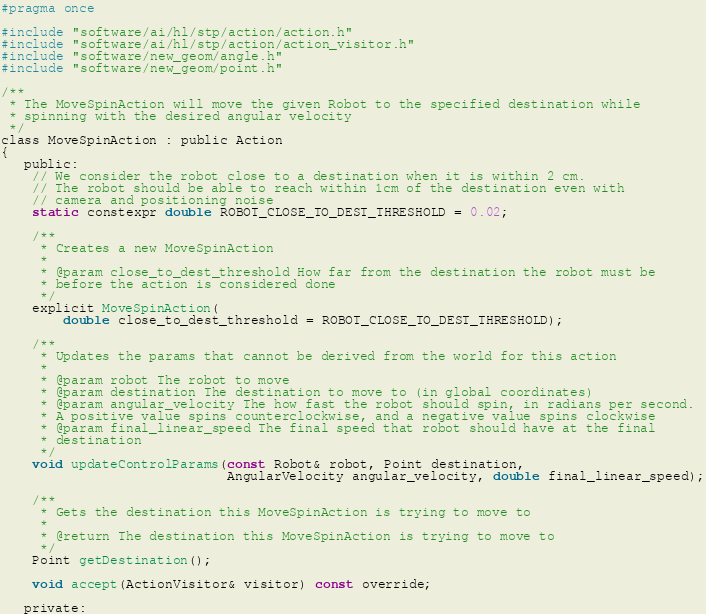<code> <loc_0><loc_0><loc_500><loc_500><_C_>#pragma once

#include "software/ai/hl/stp/action/action.h"
#include "software/ai/hl/stp/action/action_visitor.h"
#include "software/new_geom/angle.h"
#include "software/new_geom/point.h"

/**
 * The MoveSpinAction will move the given Robot to the specified destination while
 * spinning with the desired angular velocity
 */
class MoveSpinAction : public Action
{
   public:
    // We consider the robot close to a destination when it is within 2 cm.
    // The robot should be able to reach within 1cm of the destination even with
    // camera and positioning noise
    static constexpr double ROBOT_CLOSE_TO_DEST_THRESHOLD = 0.02;

    /**
     * Creates a new MoveSpinAction
     *
     * @param close_to_dest_threshold How far from the destination the robot must be
     * before the action is considered done
     */
    explicit MoveSpinAction(
        double close_to_dest_threshold = ROBOT_CLOSE_TO_DEST_THRESHOLD);

    /**
     * Updates the params that cannot be derived from the world for this action
     *
     * @param robot The robot to move
     * @param destination The destination to move to (in global coordinates)
     * @param angular_velocity The how fast the robot should spin, in radians per second.
     * A positive value spins counterclockwise, and a negative value spins clockwise
     * @param final_linear_speed The final speed that robot should have at the final
     * destination
     */
    void updateControlParams(const Robot& robot, Point destination,
                             AngularVelocity angular_velocity, double final_linear_speed);

    /**
     * Gets the destination this MoveSpinAction is trying to move to
     *
     * @return The destination this MoveSpinAction is trying to move to
     */
    Point getDestination();

    void accept(ActionVisitor& visitor) const override;

   private:</code> 